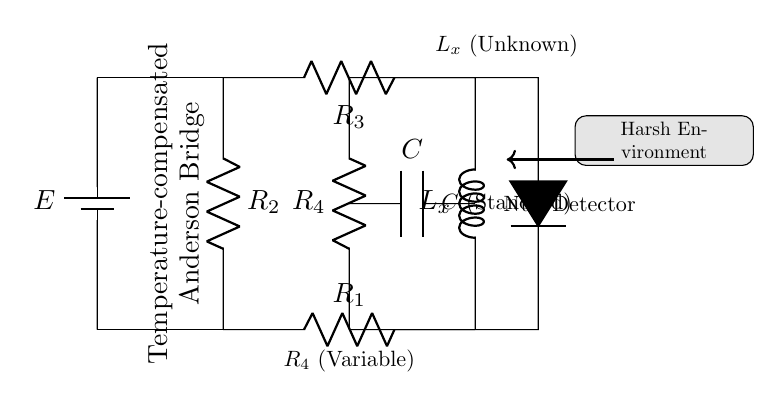What is the name of the detector in the circuit? The component labeled as “D” in the circuit represents the detector, which is indicated clearly in the diagram.
Answer: null detector What type of components are R1, R2, and R3? R1, R2, and R3 are labeled as resistors in the circuit diagram, identified by the symbol R next to each label.
Answer: resistors What does Lx represent in the circuit? The symbol L at the position labeled Lx denotes that it is an unknown inductance, as per standard circuit notation.
Answer: unknown inductance What is the function of C in the bridge circuit? The component labeled C indicates a capacitor, functioning to help balance the bridge by compensating for temperature variations in the measurements.
Answer: capacitor What role does R4 play in the Anderson bridge? R4 is a variable resistor, allowing for adjustments in the resistance to achieve balance in the bridge circuit, which is crucial for precise measurements.
Answer: variable resistor How does the circuit indicate it is designed for harsh environments? The diagram contains a labeled box illustrating "Harsh Environment," indicating that the design accommodates conditions that are challenging for electronic measurement.
Answer: harsh environment What type of bridge is depicted in the circuit? The labels in the circuit explicitly state “Temperature-compensated Anderson Bridge,” which identifies the specific bridge design used for inductance measurement.
Answer: Anderson bridge 